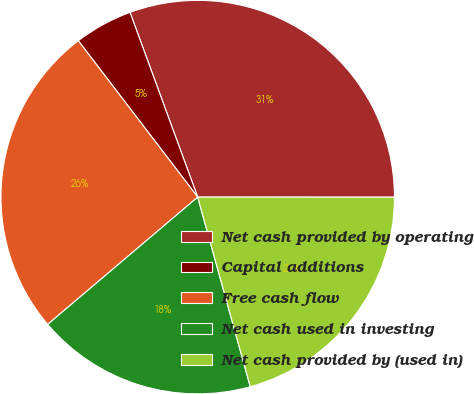<chart> <loc_0><loc_0><loc_500><loc_500><pie_chart><fcel>Net cash provided by operating<fcel>Capital additions<fcel>Free cash flow<fcel>Net cash used in investing<fcel>Net cash provided by (used in)<nl><fcel>30.6%<fcel>4.79%<fcel>25.82%<fcel>18.11%<fcel>20.69%<nl></chart> 